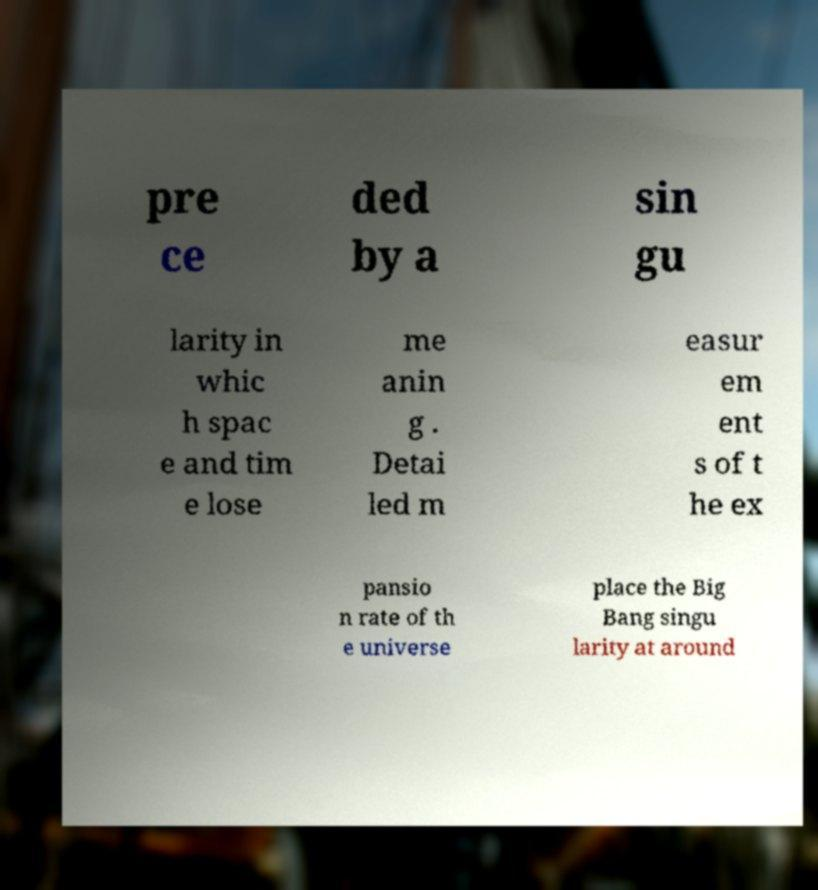Please identify and transcribe the text found in this image. pre ce ded by a sin gu larity in whic h spac e and tim e lose me anin g . Detai led m easur em ent s of t he ex pansio n rate of th e universe place the Big Bang singu larity at around 